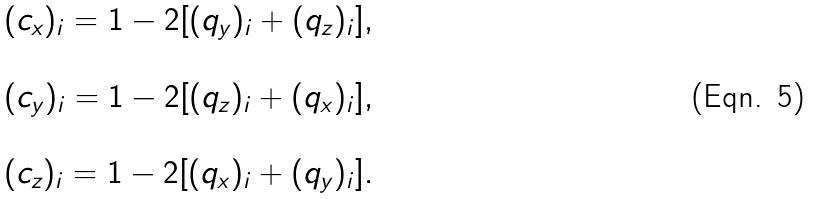Convert formula to latex. <formula><loc_0><loc_0><loc_500><loc_500>\begin{array} { l } ( c _ { x } ) _ { i } = 1 - 2 [ ( q _ { y } ) _ { i } + ( q _ { z } ) _ { i } ] , \\ \\ ( c _ { y } ) _ { i } = 1 - 2 [ ( q _ { z } ) _ { i } + ( q _ { x } ) _ { i } ] , \\ \\ ( c _ { z } ) _ { i } = 1 - 2 [ ( q _ { x } ) _ { i } + ( q _ { y } ) _ { i } ] . \end{array}</formula> 